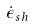Convert formula to latex. <formula><loc_0><loc_0><loc_500><loc_500>\dot { \epsilon } _ { s h }</formula> 